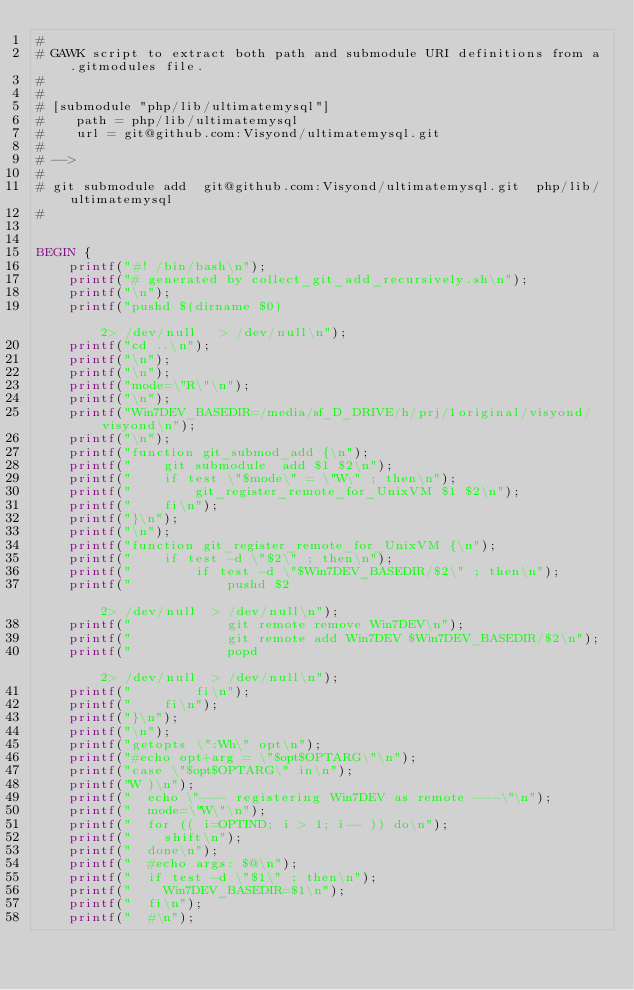Convert code to text. <code><loc_0><loc_0><loc_500><loc_500><_Awk_>#
# GAWK script to extract both path and submodule URI definitions from a .gitmodules file.
#
#
# [submodule "php/lib/ultimatemysql"]
#    path = php/lib/ultimatemysql
#    url = git@github.com:Visyond/ultimatemysql.git
#
# -->
#
# git submodule add  git@github.com:Visyond/ultimatemysql.git  php/lib/ultimatemysql
#


BEGIN {
    printf("#! /bin/bash\n");
    printf("# generated by collect_git_add_recursively.sh\n");
    printf("\n");
    printf("pushd $(dirname $0)                                                                                     2> /dev/null   > /dev/null\n");
    printf("cd ..\n");
    printf("\n");
    printf("\n");
    printf("mode=\"R\"\n");
    printf("\n");
    printf("Win7DEV_BASEDIR=/media/sf_D_DRIVE/h/prj/1original/visyond/visyond\n");
    printf("\n");
    printf("function git_submod_add {\n");
    printf("    git submodule  add $1 $2\n");
    printf("    if test \"$mode\" = \"W\" ; then\n");
    printf("        git_register_remote_for_UnixVM $1 $2\n");
    printf("    fi\n");
    printf("}\n");
    printf("\n");
    printf("function git_register_remote_for_UnixVM {\n");
    printf("    if test -d \"$2\" ; then\n");
    printf("        if test -d \"$Win7DEV_BASEDIR/$2\" ; then\n");
    printf("            pushd $2                                                                                    2> /dev/null  > /dev/null\n");
    printf("            git remote remove Win7DEV\n");
    printf("            git remote add Win7DEV $Win7DEV_BASEDIR/$2\n");
    printf("            popd                                                                                        2> /dev/null  > /dev/null\n");
    printf("        fi\n");
    printf("    fi\n");
    printf("}\n");
    printf("\n");
    printf("getopts \":Wh\" opt\n");
    printf("#echo opt+arg = \"$opt$OPTARG\"\n");
    printf("case \"$opt$OPTARG\" in\n");
    printf("W )\n");
    printf("  echo \"--- registering Win7DEV as remote ---\"\n");
    printf("  mode=\"W\"\n");
    printf("  for (( i=OPTIND; i > 1; i-- )) do\n");
    printf("    shift\n");
    printf("  done\n");
    printf("  #echo args: $@\n");
    printf("  if test -d \"$1\" ; then\n");
    printf("    Win7DEV_BASEDIR=$1\n");
    printf("  fi\n");
    printf("  #\n");</code> 